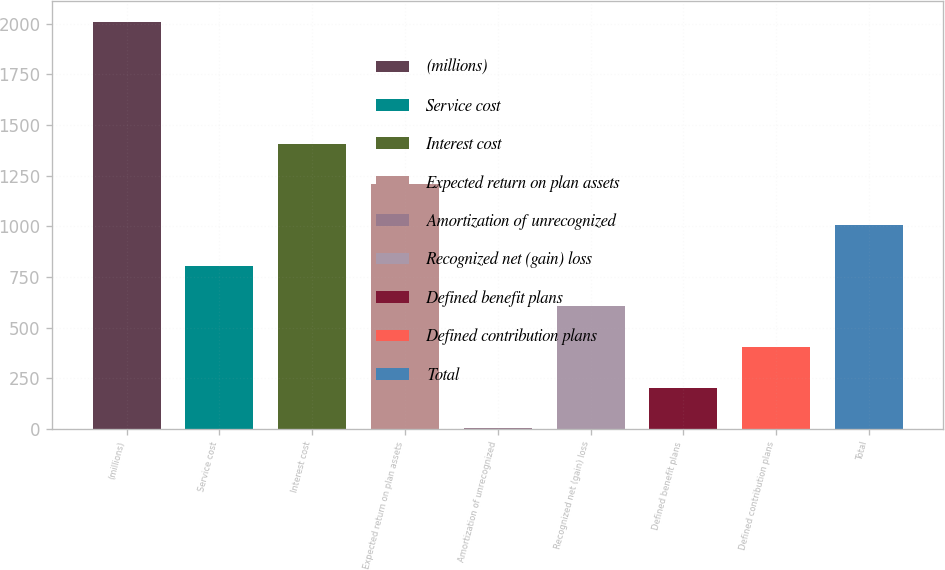Convert chart to OTSL. <chart><loc_0><loc_0><loc_500><loc_500><bar_chart><fcel>(millions)<fcel>Service cost<fcel>Interest cost<fcel>Expected return on plan assets<fcel>Amortization of unrecognized<fcel>Recognized net (gain) loss<fcel>Defined benefit plans<fcel>Defined contribution plans<fcel>Total<nl><fcel>2010<fcel>805.8<fcel>1407.9<fcel>1207.2<fcel>3<fcel>605.1<fcel>203.7<fcel>404.4<fcel>1006.5<nl></chart> 